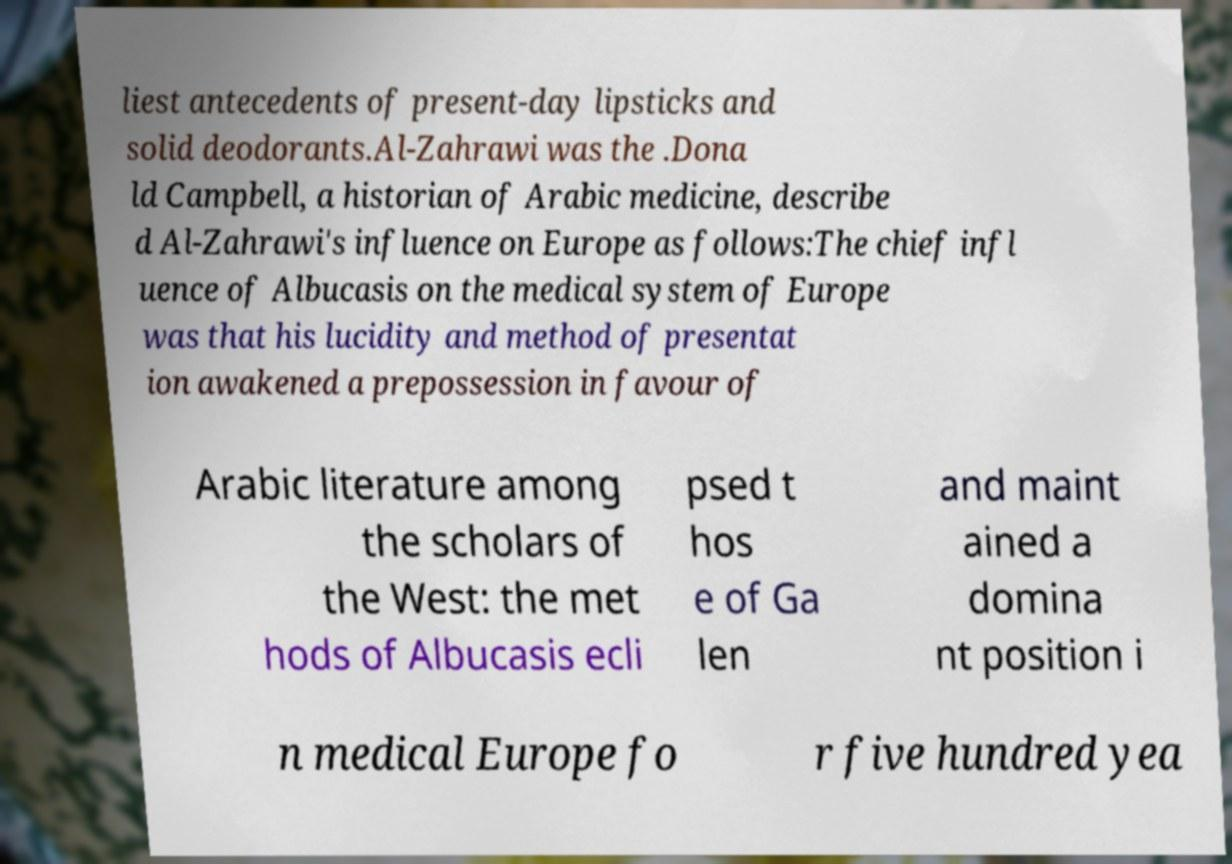I need the written content from this picture converted into text. Can you do that? liest antecedents of present-day lipsticks and solid deodorants.Al-Zahrawi was the .Dona ld Campbell, a historian of Arabic medicine, describe d Al-Zahrawi's influence on Europe as follows:The chief infl uence of Albucasis on the medical system of Europe was that his lucidity and method of presentat ion awakened a prepossession in favour of Arabic literature among the scholars of the West: the met hods of Albucasis ecli psed t hos e of Ga len and maint ained a domina nt position i n medical Europe fo r five hundred yea 